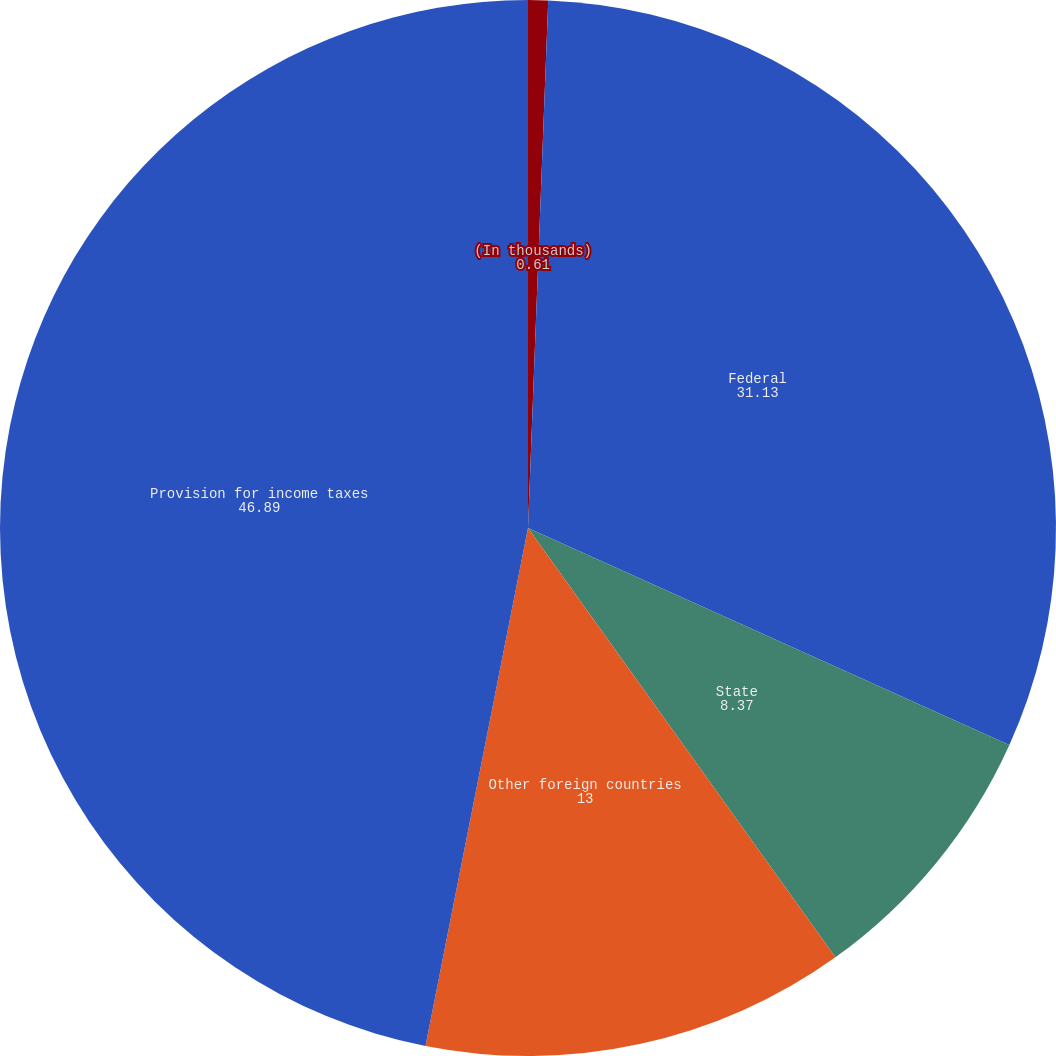Convert chart to OTSL. <chart><loc_0><loc_0><loc_500><loc_500><pie_chart><fcel>(In thousands)<fcel>Federal<fcel>State<fcel>Other foreign countries<fcel>Provision for income taxes<nl><fcel>0.61%<fcel>31.13%<fcel>8.37%<fcel>13.0%<fcel>46.89%<nl></chart> 